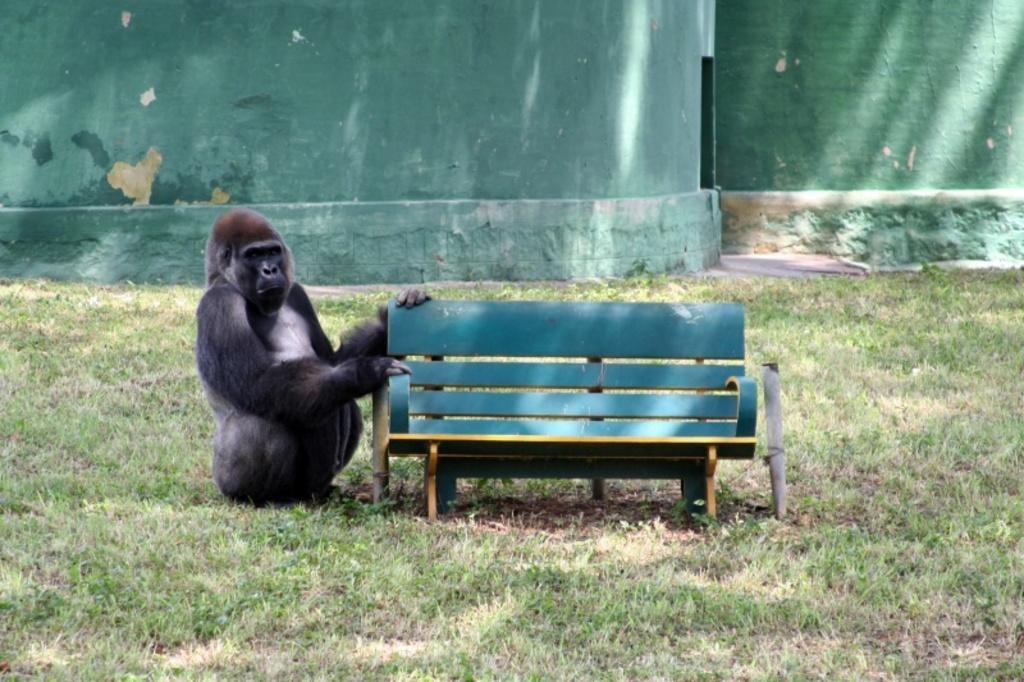Could you give a brief overview of what you see in this image? In this image, we can see chimpanzee is sat near the bench. At the bottom, we can see grass. And background we can see green color wall. 